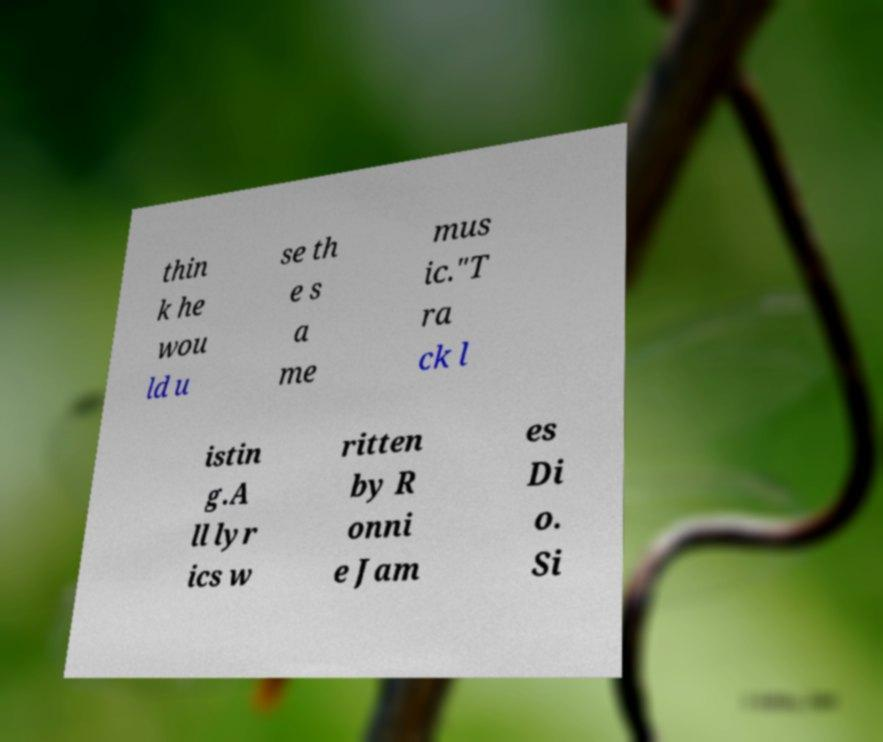Could you assist in decoding the text presented in this image and type it out clearly? thin k he wou ld u se th e s a me mus ic."T ra ck l istin g.A ll lyr ics w ritten by R onni e Jam es Di o. Si 